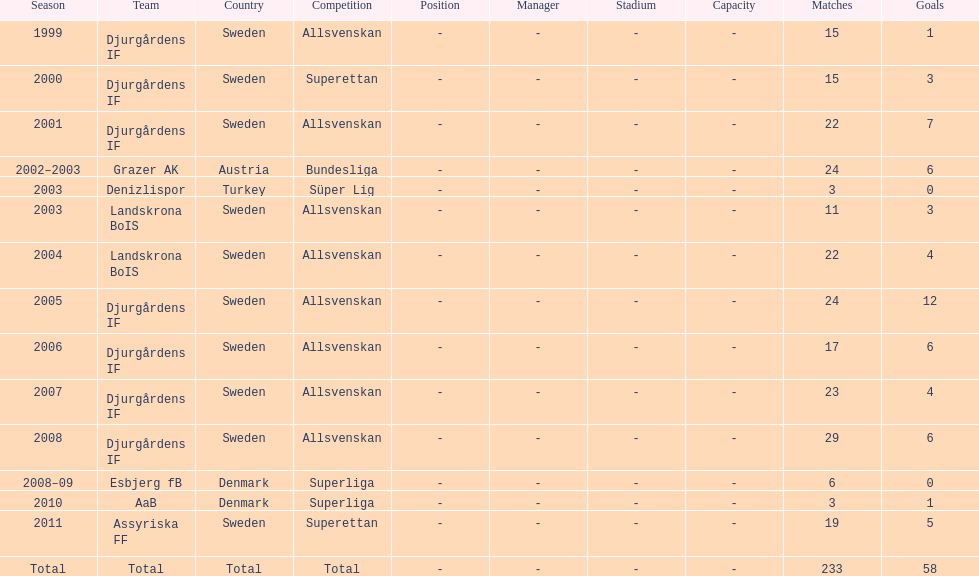How many teams had above 20 matches in the season? 6. Give me the full table as a dictionary. {'header': ['Season', 'Team', 'Country', 'Competition', 'Position', 'Manager', 'Stadium', 'Capacity', 'Matches', 'Goals'], 'rows': [['1999', 'Djurgårdens IF', 'Sweden', 'Allsvenskan', '-', '-', '-', '-', '15', '1'], ['2000', 'Djurgårdens IF', 'Sweden', 'Superettan', '-', '-', '-', '-', '15', '3'], ['2001', 'Djurgårdens IF', 'Sweden', 'Allsvenskan', '-', '-', '-', '-', '22', '7'], ['2002–2003', 'Grazer AK', 'Austria', 'Bundesliga', '-', '-', '-', '-', '24', '6'], ['2003', 'Denizlispor', 'Turkey', 'Süper Lig', '-', '-', '-', '-', '3', '0'], ['2003', 'Landskrona BoIS', 'Sweden', 'Allsvenskan', '-', '-', '-', '-', '11', '3'], ['2004', 'Landskrona BoIS', 'Sweden', 'Allsvenskan', '-', '-', '-', '-', '22', '4'], ['2005', 'Djurgårdens IF', 'Sweden', 'Allsvenskan', '-', '-', '-', '-', '24', '12'], ['2006', 'Djurgårdens IF', 'Sweden', 'Allsvenskan', '-', '-', '-', '-', '17', '6'], ['2007', 'Djurgårdens IF', 'Sweden', 'Allsvenskan', '-', '-', '-', '-', '23', '4'], ['2008', 'Djurgårdens IF', 'Sweden', 'Allsvenskan', '-', '-', '-', '-', '29', '6'], ['2008–09', 'Esbjerg fB', 'Denmark', 'Superliga', '-', '-', '-', '-', '6', '0'], ['2010', 'AaB', 'Denmark', 'Superliga', '-', '-', '-', '-', '3', '1'], ['2011', 'Assyriska FF', 'Sweden', 'Superettan', '-', '-', '-', '-', '19', '5'], ['Total', 'Total', 'Total', 'Total', '-', '-', '-', '-', '233', '58']]} 